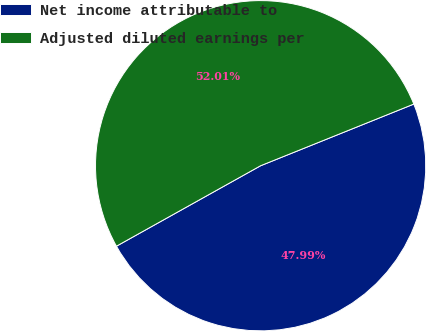Convert chart. <chart><loc_0><loc_0><loc_500><loc_500><pie_chart><fcel>Net income attributable to<fcel>Adjusted diluted earnings per<nl><fcel>47.99%<fcel>52.01%<nl></chart> 